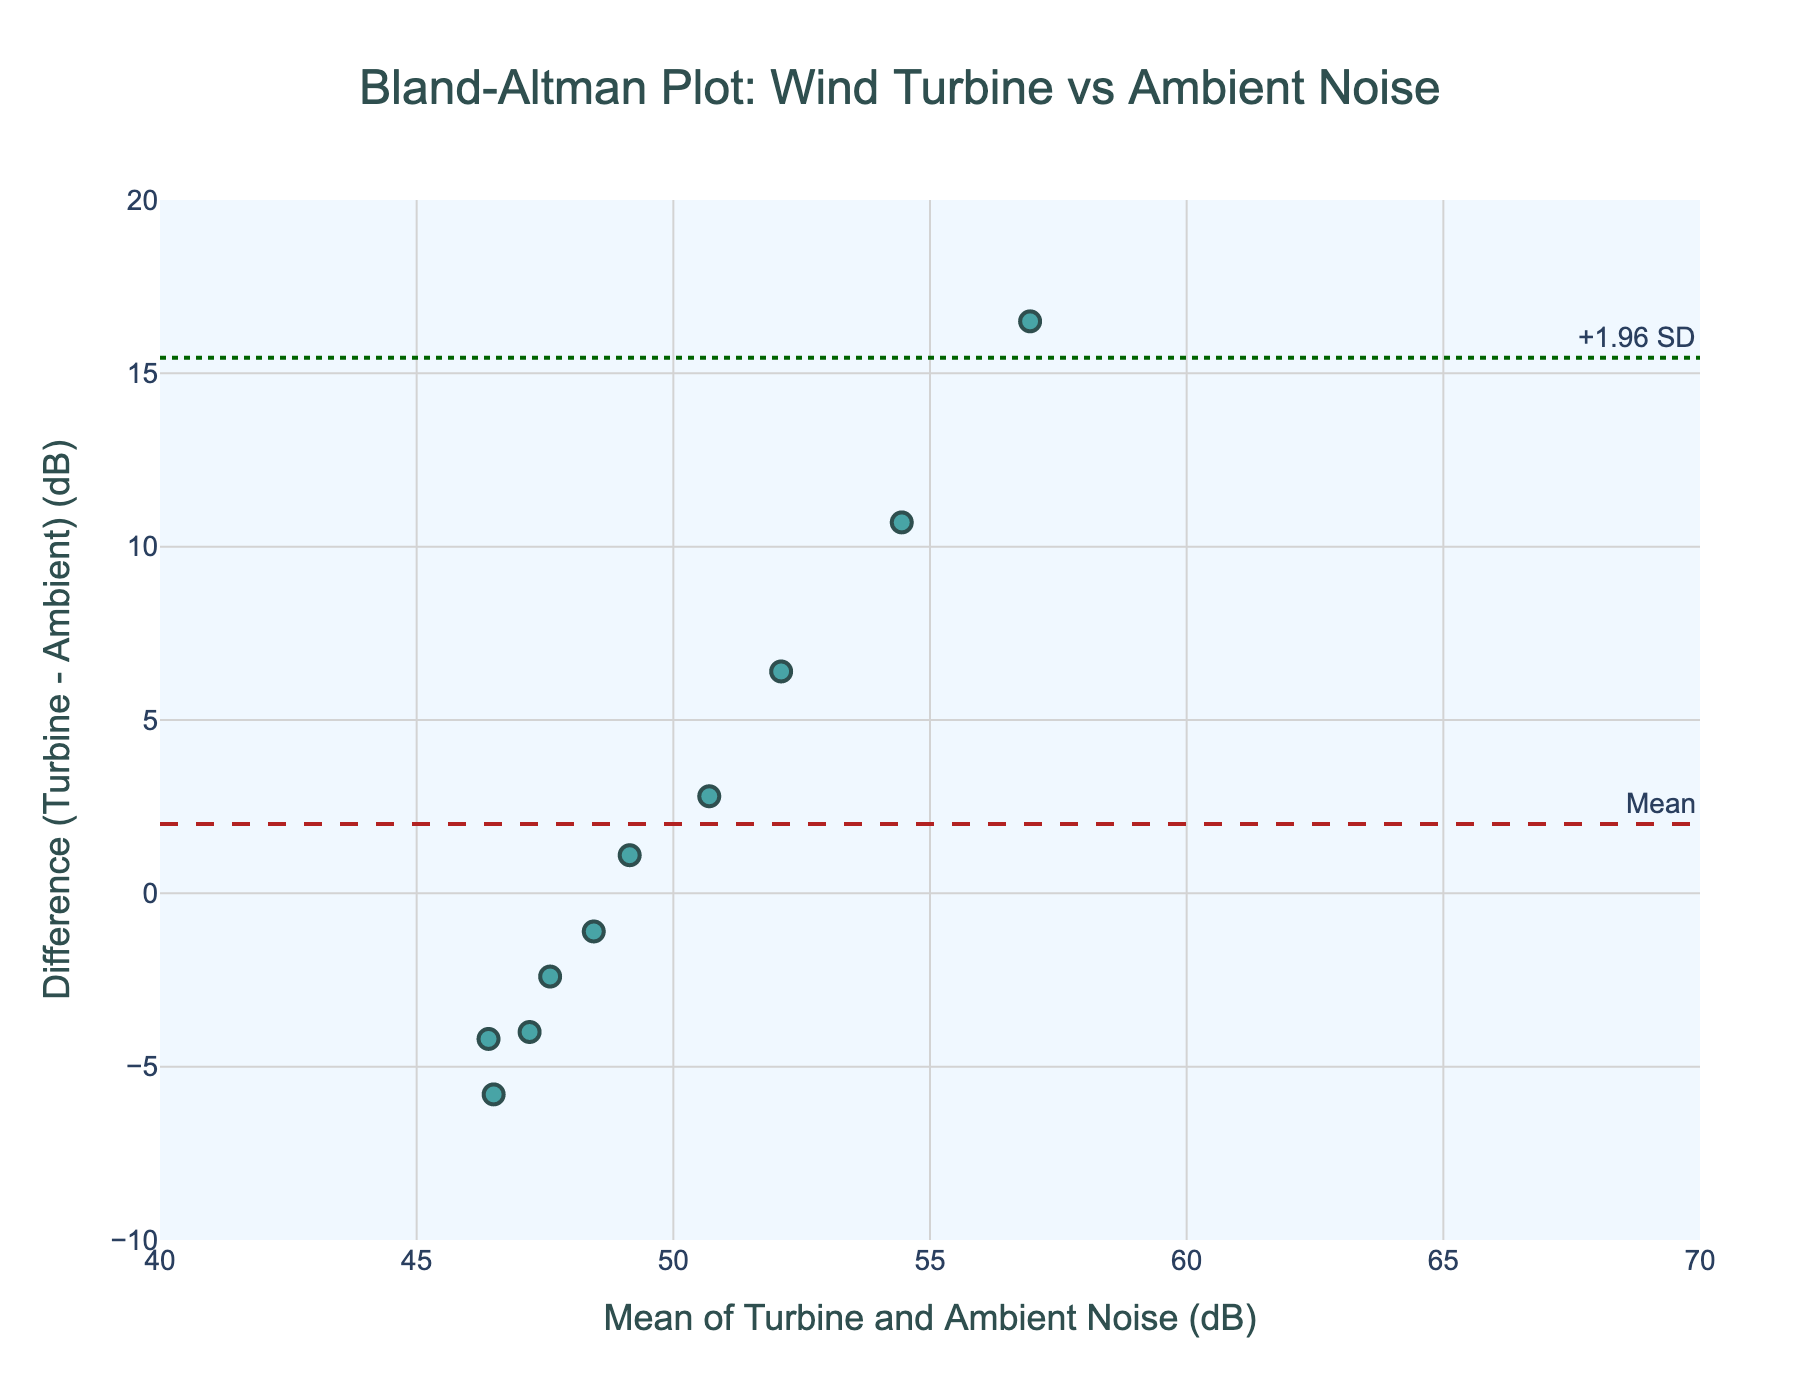What is the title of the plot? The title is found at the top center of the plot and says what the plot is about. It reads 'Bland-Altman Plot: Wind Turbine vs Ambient Noise'.
Answer: Bland-Altman Plot: Wind Turbine vs Ambient Noise How many data points are plotted on the figure? Count the number of markers (data points) on the scatter plot; it matches the number of rows in the dataset, which is 10.
Answer: 10 What is the mean difference between turbine noise and ambient noise? The mean difference is represented as a dashed line on the Y-axis and annotated with the 'Mean' label. It is found at the y-coordinate value where this line intersects.
Answer: -4.49 dB What is the range of the mean of turbine and ambient noise values on the X-axis? Look at the minimum and maximum values on the X-axis to determine the range. The data points range from around 46.15 to 57.3 dB.
Answer: 46.15 to 57.3 dB What are the upper and lower limits of agreement on the plot? The upper limit of agreement (upper dotted line) and the lower limit of agreement (lower dotted line) are labeled with '+1.96 SD' and '-1.96 SD' respectively. The lines intersect the Y-axis at 7.15 dB (upper) and -16.13 dB (lower).
Answer: 7.15 dB (upper); -16.13 dB (lower) Which data point has the highest mean value, and what is its distance from the turbine? Identify the highest data point on the X-axis (mean value) and trace it back to the given distance in the dataset. The highest mean value is around 57.3 dB, which corresponds to the 5m distance from the turbine.
Answer: 5 meters How does the noise difference change as the distance from the turbine increases? Observe the scatter points' trend along the X-axis (mean values) as the distance increases. The difference decreases as the distance from the turbine increases, with earlier points showing higher differences that taper off.
Answer: Decreases Is there any data point for which the turbine noise is less than the ambient noise? Check the points plotted below the zero line on the Y-axis (Difference). Points with negative values indicate that the turbine noise is less than the ambient noise. There are no such points.
Answer: No Are all data points within the limits of agreement? Compare the Y-values (Difference) of the data points to the upper and lower limits of agreement. Ensure that no data point extends beyond these limits. All points are between the upper and lower dotted lines.
Answer: Yes 